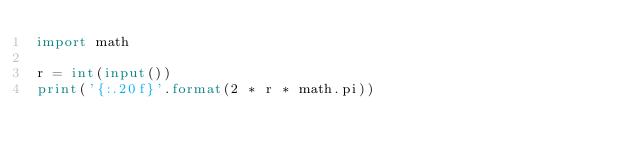<code> <loc_0><loc_0><loc_500><loc_500><_Python_>import math

r = int(input())
print('{:.20f}'.format(2 * r * math.pi))</code> 